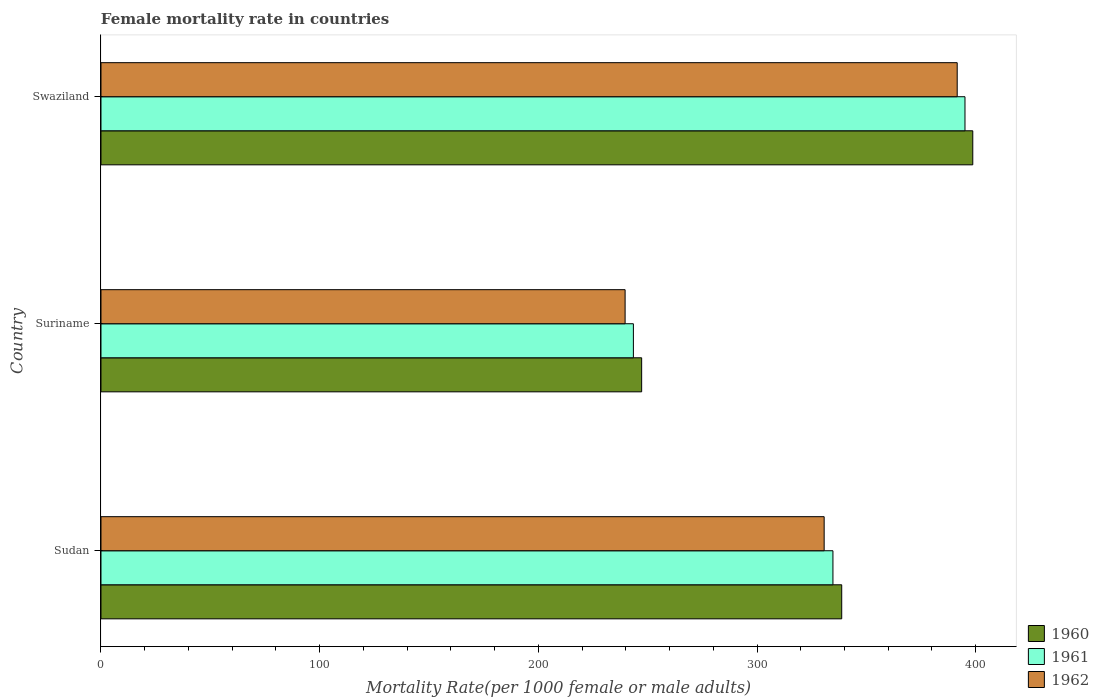How many different coloured bars are there?
Make the answer very short. 3. How many bars are there on the 3rd tick from the top?
Give a very brief answer. 3. How many bars are there on the 2nd tick from the bottom?
Offer a very short reply. 3. What is the label of the 1st group of bars from the top?
Provide a succinct answer. Swaziland. In how many cases, is the number of bars for a given country not equal to the number of legend labels?
Provide a short and direct response. 0. What is the female mortality rate in 1962 in Sudan?
Your answer should be very brief. 330.69. Across all countries, what is the maximum female mortality rate in 1962?
Provide a short and direct response. 391.53. Across all countries, what is the minimum female mortality rate in 1961?
Provide a succinct answer. 243.46. In which country was the female mortality rate in 1961 maximum?
Provide a short and direct response. Swaziland. In which country was the female mortality rate in 1961 minimum?
Your answer should be very brief. Suriname. What is the total female mortality rate in 1961 in the graph?
Your response must be concise. 973.26. What is the difference between the female mortality rate in 1960 in Sudan and that in Swaziland?
Provide a succinct answer. -59.93. What is the difference between the female mortality rate in 1961 in Suriname and the female mortality rate in 1962 in Swaziland?
Make the answer very short. -148.08. What is the average female mortality rate in 1961 per country?
Offer a very short reply. 324.42. What is the difference between the female mortality rate in 1962 and female mortality rate in 1961 in Sudan?
Your response must be concise. -4.02. In how many countries, is the female mortality rate in 1960 greater than 280 ?
Give a very brief answer. 2. What is the ratio of the female mortality rate in 1960 in Sudan to that in Suriname?
Your answer should be compact. 1.37. Is the female mortality rate in 1962 in Sudan less than that in Swaziland?
Keep it short and to the point. Yes. Is the difference between the female mortality rate in 1962 in Sudan and Swaziland greater than the difference between the female mortality rate in 1961 in Sudan and Swaziland?
Provide a short and direct response. No. What is the difference between the highest and the second highest female mortality rate in 1960?
Keep it short and to the point. 59.93. What is the difference between the highest and the lowest female mortality rate in 1960?
Offer a terse response. 151.41. In how many countries, is the female mortality rate in 1960 greater than the average female mortality rate in 1960 taken over all countries?
Your answer should be compact. 2. What does the 2nd bar from the top in Suriname represents?
Your answer should be compact. 1961. What does the 3rd bar from the bottom in Sudan represents?
Your answer should be compact. 1962. Are the values on the major ticks of X-axis written in scientific E-notation?
Give a very brief answer. No. Does the graph contain grids?
Your response must be concise. No. What is the title of the graph?
Provide a short and direct response. Female mortality rate in countries. What is the label or title of the X-axis?
Keep it short and to the point. Mortality Rate(per 1000 female or male adults). What is the label or title of the Y-axis?
Offer a very short reply. Country. What is the Mortality Rate(per 1000 female or male adults) of 1960 in Sudan?
Your answer should be very brief. 338.73. What is the Mortality Rate(per 1000 female or male adults) in 1961 in Sudan?
Your response must be concise. 334.71. What is the Mortality Rate(per 1000 female or male adults) of 1962 in Sudan?
Provide a short and direct response. 330.69. What is the Mortality Rate(per 1000 female or male adults) of 1960 in Suriname?
Your answer should be compact. 247.24. What is the Mortality Rate(per 1000 female or male adults) in 1961 in Suriname?
Make the answer very short. 243.46. What is the Mortality Rate(per 1000 female or male adults) of 1962 in Suriname?
Give a very brief answer. 239.67. What is the Mortality Rate(per 1000 female or male adults) in 1960 in Swaziland?
Offer a very short reply. 398.66. What is the Mortality Rate(per 1000 female or male adults) in 1961 in Swaziland?
Provide a succinct answer. 395.1. What is the Mortality Rate(per 1000 female or male adults) in 1962 in Swaziland?
Your answer should be very brief. 391.53. Across all countries, what is the maximum Mortality Rate(per 1000 female or male adults) of 1960?
Provide a succinct answer. 398.66. Across all countries, what is the maximum Mortality Rate(per 1000 female or male adults) of 1961?
Ensure brevity in your answer.  395.1. Across all countries, what is the maximum Mortality Rate(per 1000 female or male adults) in 1962?
Give a very brief answer. 391.53. Across all countries, what is the minimum Mortality Rate(per 1000 female or male adults) of 1960?
Provide a short and direct response. 247.24. Across all countries, what is the minimum Mortality Rate(per 1000 female or male adults) in 1961?
Offer a terse response. 243.46. Across all countries, what is the minimum Mortality Rate(per 1000 female or male adults) in 1962?
Keep it short and to the point. 239.67. What is the total Mortality Rate(per 1000 female or male adults) in 1960 in the graph?
Provide a succinct answer. 984.63. What is the total Mortality Rate(per 1000 female or male adults) of 1961 in the graph?
Offer a terse response. 973.26. What is the total Mortality Rate(per 1000 female or male adults) of 1962 in the graph?
Keep it short and to the point. 961.9. What is the difference between the Mortality Rate(per 1000 female or male adults) in 1960 in Sudan and that in Suriname?
Your answer should be very brief. 91.49. What is the difference between the Mortality Rate(per 1000 female or male adults) in 1961 in Sudan and that in Suriname?
Offer a terse response. 91.25. What is the difference between the Mortality Rate(per 1000 female or male adults) of 1962 in Sudan and that in Suriname?
Provide a short and direct response. 91.02. What is the difference between the Mortality Rate(per 1000 female or male adults) of 1960 in Sudan and that in Swaziland?
Provide a succinct answer. -59.93. What is the difference between the Mortality Rate(per 1000 female or male adults) of 1961 in Sudan and that in Swaziland?
Your answer should be compact. -60.38. What is the difference between the Mortality Rate(per 1000 female or male adults) of 1962 in Sudan and that in Swaziland?
Keep it short and to the point. -60.84. What is the difference between the Mortality Rate(per 1000 female or male adults) in 1960 in Suriname and that in Swaziland?
Ensure brevity in your answer.  -151.41. What is the difference between the Mortality Rate(per 1000 female or male adults) in 1961 in Suriname and that in Swaziland?
Provide a short and direct response. -151.64. What is the difference between the Mortality Rate(per 1000 female or male adults) of 1962 in Suriname and that in Swaziland?
Ensure brevity in your answer.  -151.86. What is the difference between the Mortality Rate(per 1000 female or male adults) of 1960 in Sudan and the Mortality Rate(per 1000 female or male adults) of 1961 in Suriname?
Your answer should be compact. 95.27. What is the difference between the Mortality Rate(per 1000 female or male adults) of 1960 in Sudan and the Mortality Rate(per 1000 female or male adults) of 1962 in Suriname?
Offer a very short reply. 99.06. What is the difference between the Mortality Rate(per 1000 female or male adults) in 1961 in Sudan and the Mortality Rate(per 1000 female or male adults) in 1962 in Suriname?
Give a very brief answer. 95.04. What is the difference between the Mortality Rate(per 1000 female or male adults) in 1960 in Sudan and the Mortality Rate(per 1000 female or male adults) in 1961 in Swaziland?
Ensure brevity in your answer.  -56.37. What is the difference between the Mortality Rate(per 1000 female or male adults) in 1960 in Sudan and the Mortality Rate(per 1000 female or male adults) in 1962 in Swaziland?
Provide a succinct answer. -52.8. What is the difference between the Mortality Rate(per 1000 female or male adults) of 1961 in Sudan and the Mortality Rate(per 1000 female or male adults) of 1962 in Swaziland?
Give a very brief answer. -56.82. What is the difference between the Mortality Rate(per 1000 female or male adults) of 1960 in Suriname and the Mortality Rate(per 1000 female or male adults) of 1961 in Swaziland?
Your answer should be very brief. -147.85. What is the difference between the Mortality Rate(per 1000 female or male adults) of 1960 in Suriname and the Mortality Rate(per 1000 female or male adults) of 1962 in Swaziland?
Offer a very short reply. -144.29. What is the difference between the Mortality Rate(per 1000 female or male adults) of 1961 in Suriname and the Mortality Rate(per 1000 female or male adults) of 1962 in Swaziland?
Offer a terse response. -148.08. What is the average Mortality Rate(per 1000 female or male adults) in 1960 per country?
Provide a succinct answer. 328.21. What is the average Mortality Rate(per 1000 female or male adults) of 1961 per country?
Provide a succinct answer. 324.42. What is the average Mortality Rate(per 1000 female or male adults) of 1962 per country?
Make the answer very short. 320.63. What is the difference between the Mortality Rate(per 1000 female or male adults) in 1960 and Mortality Rate(per 1000 female or male adults) in 1961 in Sudan?
Keep it short and to the point. 4.02. What is the difference between the Mortality Rate(per 1000 female or male adults) of 1960 and Mortality Rate(per 1000 female or male adults) of 1962 in Sudan?
Make the answer very short. 8.03. What is the difference between the Mortality Rate(per 1000 female or male adults) in 1961 and Mortality Rate(per 1000 female or male adults) in 1962 in Sudan?
Give a very brief answer. 4.02. What is the difference between the Mortality Rate(per 1000 female or male adults) of 1960 and Mortality Rate(per 1000 female or male adults) of 1961 in Suriname?
Your answer should be very brief. 3.79. What is the difference between the Mortality Rate(per 1000 female or male adults) in 1960 and Mortality Rate(per 1000 female or male adults) in 1962 in Suriname?
Offer a terse response. 7.57. What is the difference between the Mortality Rate(per 1000 female or male adults) in 1961 and Mortality Rate(per 1000 female or male adults) in 1962 in Suriname?
Make the answer very short. 3.79. What is the difference between the Mortality Rate(per 1000 female or male adults) in 1960 and Mortality Rate(per 1000 female or male adults) in 1961 in Swaziland?
Keep it short and to the point. 3.56. What is the difference between the Mortality Rate(per 1000 female or male adults) of 1960 and Mortality Rate(per 1000 female or male adults) of 1962 in Swaziland?
Ensure brevity in your answer.  7.12. What is the difference between the Mortality Rate(per 1000 female or male adults) of 1961 and Mortality Rate(per 1000 female or male adults) of 1962 in Swaziland?
Ensure brevity in your answer.  3.56. What is the ratio of the Mortality Rate(per 1000 female or male adults) of 1960 in Sudan to that in Suriname?
Keep it short and to the point. 1.37. What is the ratio of the Mortality Rate(per 1000 female or male adults) in 1961 in Sudan to that in Suriname?
Give a very brief answer. 1.37. What is the ratio of the Mortality Rate(per 1000 female or male adults) of 1962 in Sudan to that in Suriname?
Give a very brief answer. 1.38. What is the ratio of the Mortality Rate(per 1000 female or male adults) in 1960 in Sudan to that in Swaziland?
Your answer should be very brief. 0.85. What is the ratio of the Mortality Rate(per 1000 female or male adults) of 1961 in Sudan to that in Swaziland?
Provide a succinct answer. 0.85. What is the ratio of the Mortality Rate(per 1000 female or male adults) of 1962 in Sudan to that in Swaziland?
Provide a succinct answer. 0.84. What is the ratio of the Mortality Rate(per 1000 female or male adults) in 1960 in Suriname to that in Swaziland?
Provide a short and direct response. 0.62. What is the ratio of the Mortality Rate(per 1000 female or male adults) of 1961 in Suriname to that in Swaziland?
Your answer should be compact. 0.62. What is the ratio of the Mortality Rate(per 1000 female or male adults) in 1962 in Suriname to that in Swaziland?
Provide a short and direct response. 0.61. What is the difference between the highest and the second highest Mortality Rate(per 1000 female or male adults) of 1960?
Provide a succinct answer. 59.93. What is the difference between the highest and the second highest Mortality Rate(per 1000 female or male adults) in 1961?
Provide a short and direct response. 60.38. What is the difference between the highest and the second highest Mortality Rate(per 1000 female or male adults) in 1962?
Ensure brevity in your answer.  60.84. What is the difference between the highest and the lowest Mortality Rate(per 1000 female or male adults) of 1960?
Give a very brief answer. 151.41. What is the difference between the highest and the lowest Mortality Rate(per 1000 female or male adults) of 1961?
Provide a succinct answer. 151.64. What is the difference between the highest and the lowest Mortality Rate(per 1000 female or male adults) in 1962?
Give a very brief answer. 151.86. 